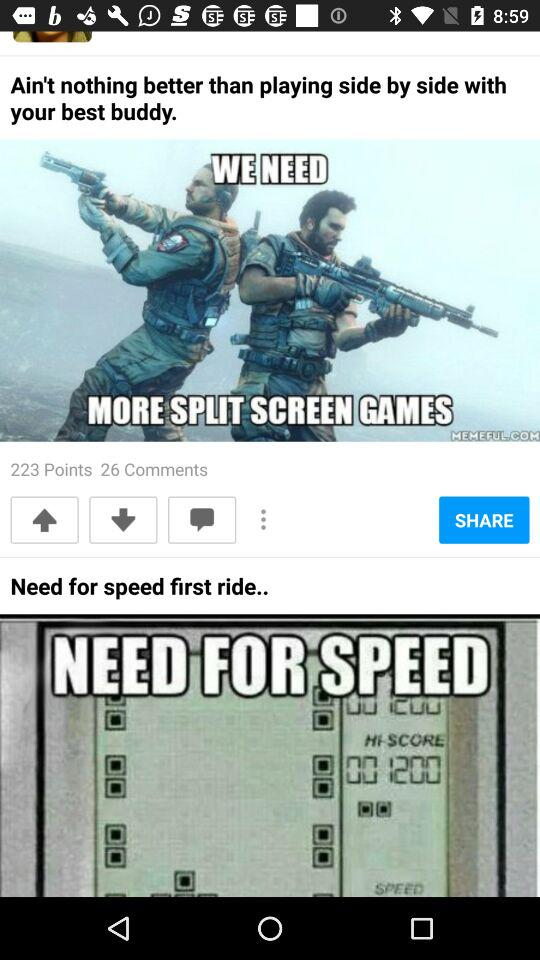How many more points are there than comments?
Answer the question using a single word or phrase. 197 